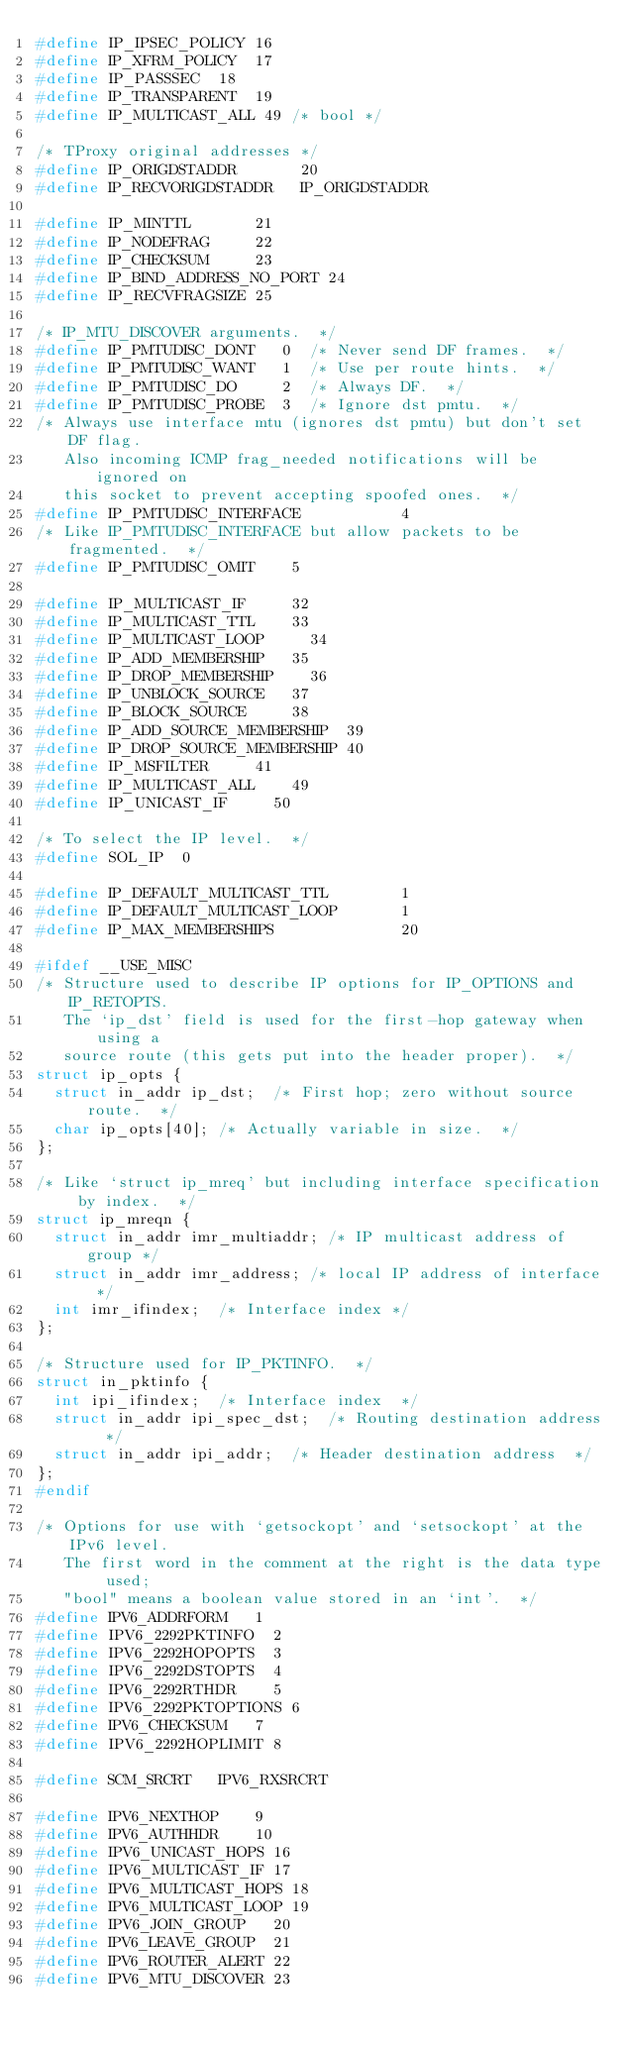<code> <loc_0><loc_0><loc_500><loc_500><_C_>#define IP_IPSEC_POLICY 16
#define IP_XFRM_POLICY	17
#define IP_PASSSEC	18
#define IP_TRANSPARENT	19
#define IP_MULTICAST_ALL 49	/* bool */

/* TProxy original addresses */
#define IP_ORIGDSTADDR       20
#define IP_RECVORIGDSTADDR   IP_ORIGDSTADDR

#define IP_MINTTL       21
#define IP_NODEFRAG     22
#define IP_CHECKSUM     23
#define IP_BIND_ADDRESS_NO_PORT 24
#define IP_RECVFRAGSIZE 25

/* IP_MTU_DISCOVER arguments.  */
#define IP_PMTUDISC_DONT   0	/* Never send DF frames.  */
#define IP_PMTUDISC_WANT   1	/* Use per route hints.  */
#define IP_PMTUDISC_DO     2	/* Always DF.  */
#define IP_PMTUDISC_PROBE  3	/* Ignore dst pmtu.  */
/* Always use interface mtu (ignores dst pmtu) but don't set DF flag.
   Also incoming ICMP frag_needed notifications will be ignored on
   this socket to prevent accepting spoofed ones.  */
#define IP_PMTUDISC_INTERFACE           4
/* Like IP_PMTUDISC_INTERFACE but allow packets to be fragmented.  */
#define IP_PMTUDISC_OMIT		5

#define IP_MULTICAST_IF			32
#define IP_MULTICAST_TTL 		33
#define IP_MULTICAST_LOOP 		34
#define IP_ADD_MEMBERSHIP		35
#define IP_DROP_MEMBERSHIP		36
#define IP_UNBLOCK_SOURCE		37
#define IP_BLOCK_SOURCE			38
#define IP_ADD_SOURCE_MEMBERSHIP	39
#define IP_DROP_SOURCE_MEMBERSHIP	40
#define IP_MSFILTER			41
#define IP_MULTICAST_ALL		49
#define IP_UNICAST_IF			50

/* To select the IP level.  */
#define SOL_IP	0

#define IP_DEFAULT_MULTICAST_TTL        1
#define IP_DEFAULT_MULTICAST_LOOP       1
#define IP_MAX_MEMBERSHIPS              20

#ifdef __USE_MISC
/* Structure used to describe IP options for IP_OPTIONS and IP_RETOPTS.
   The `ip_dst' field is used for the first-hop gateway when using a
   source route (this gets put into the header proper).  */
struct ip_opts {
	struct in_addr ip_dst;	/* First hop; zero without source route.  */
	char ip_opts[40];	/* Actually variable in size.  */
};

/* Like `struct ip_mreq' but including interface specification by index.  */
struct ip_mreqn {
	struct in_addr imr_multiaddr;	/* IP multicast address of group */
	struct in_addr imr_address;	/* local IP address of interface */
	int imr_ifindex;	/* Interface index */
};

/* Structure used for IP_PKTINFO.  */
struct in_pktinfo {
	int ipi_ifindex;	/* Interface index  */
	struct in_addr ipi_spec_dst;	/* Routing destination address  */
	struct in_addr ipi_addr;	/* Header destination address  */
};
#endif

/* Options for use with `getsockopt' and `setsockopt' at the IPv6 level.
   The first word in the comment at the right is the data type used;
   "bool" means a boolean value stored in an `int'.  */
#define IPV6_ADDRFORM		1
#define IPV6_2292PKTINFO	2
#define IPV6_2292HOPOPTS	3
#define IPV6_2292DSTOPTS	4
#define IPV6_2292RTHDR		5
#define IPV6_2292PKTOPTIONS	6
#define IPV6_CHECKSUM		7
#define IPV6_2292HOPLIMIT	8

#define SCM_SRCRT		IPV6_RXSRCRT

#define IPV6_NEXTHOP		9
#define IPV6_AUTHHDR		10
#define IPV6_UNICAST_HOPS	16
#define IPV6_MULTICAST_IF	17
#define IPV6_MULTICAST_HOPS	18
#define IPV6_MULTICAST_LOOP	19
#define IPV6_JOIN_GROUP		20
#define IPV6_LEAVE_GROUP	21
#define IPV6_ROUTER_ALERT	22
#define IPV6_MTU_DISCOVER	23</code> 